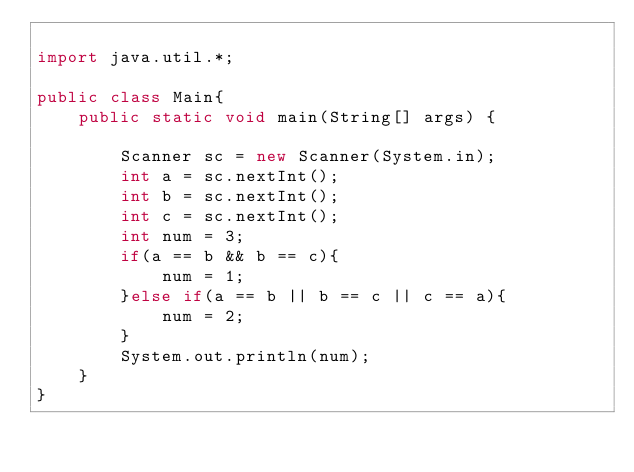<code> <loc_0><loc_0><loc_500><loc_500><_Java_>
import java.util.*;

public class Main{
    public static void main(String[] args) {
        
        Scanner sc = new Scanner(System.in);
        int a = sc.nextInt();
        int b = sc.nextInt();
        int c = sc.nextInt();
        int num = 3;
        if(a == b && b == c){
            num = 1;
        }else if(a == b || b == c || c == a){
            num = 2;
        }
        System.out.println(num);
    }
}</code> 